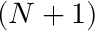Convert formula to latex. <formula><loc_0><loc_0><loc_500><loc_500>( N + 1 )</formula> 